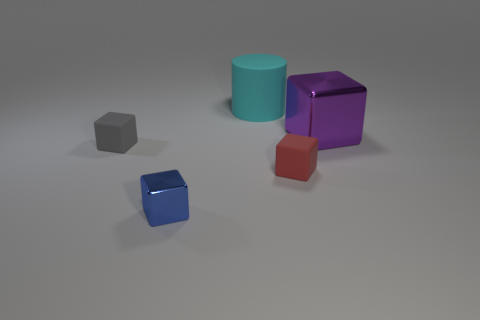There is a blue object; is it the same size as the object that is behind the large shiny object?
Your response must be concise. No. Is there any other thing that is the same shape as the cyan object?
Your response must be concise. No. What is the color of the large metal thing that is the same shape as the small metal object?
Your answer should be compact. Purple. Is the size of the blue block the same as the cyan cylinder?
Provide a short and direct response. No. How many other objects are the same size as the cyan matte cylinder?
Offer a terse response. 1. How many objects are either things in front of the gray matte cube or metallic cubes that are behind the small blue metallic cube?
Give a very brief answer. 3. The object that is the same size as the purple shiny block is what shape?
Your answer should be compact. Cylinder. What is the size of the blue thing that is made of the same material as the big block?
Your answer should be compact. Small. Is the shape of the red matte thing the same as the large purple object?
Ensure brevity in your answer.  Yes. There is a matte object that is the same size as the purple metal thing; what is its color?
Offer a terse response. Cyan. 